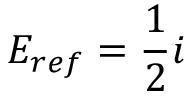<formula> <loc_0><loc_0><loc_500><loc_500>E _ { r e f } = \frac { 1 } { 2 } i</formula> 